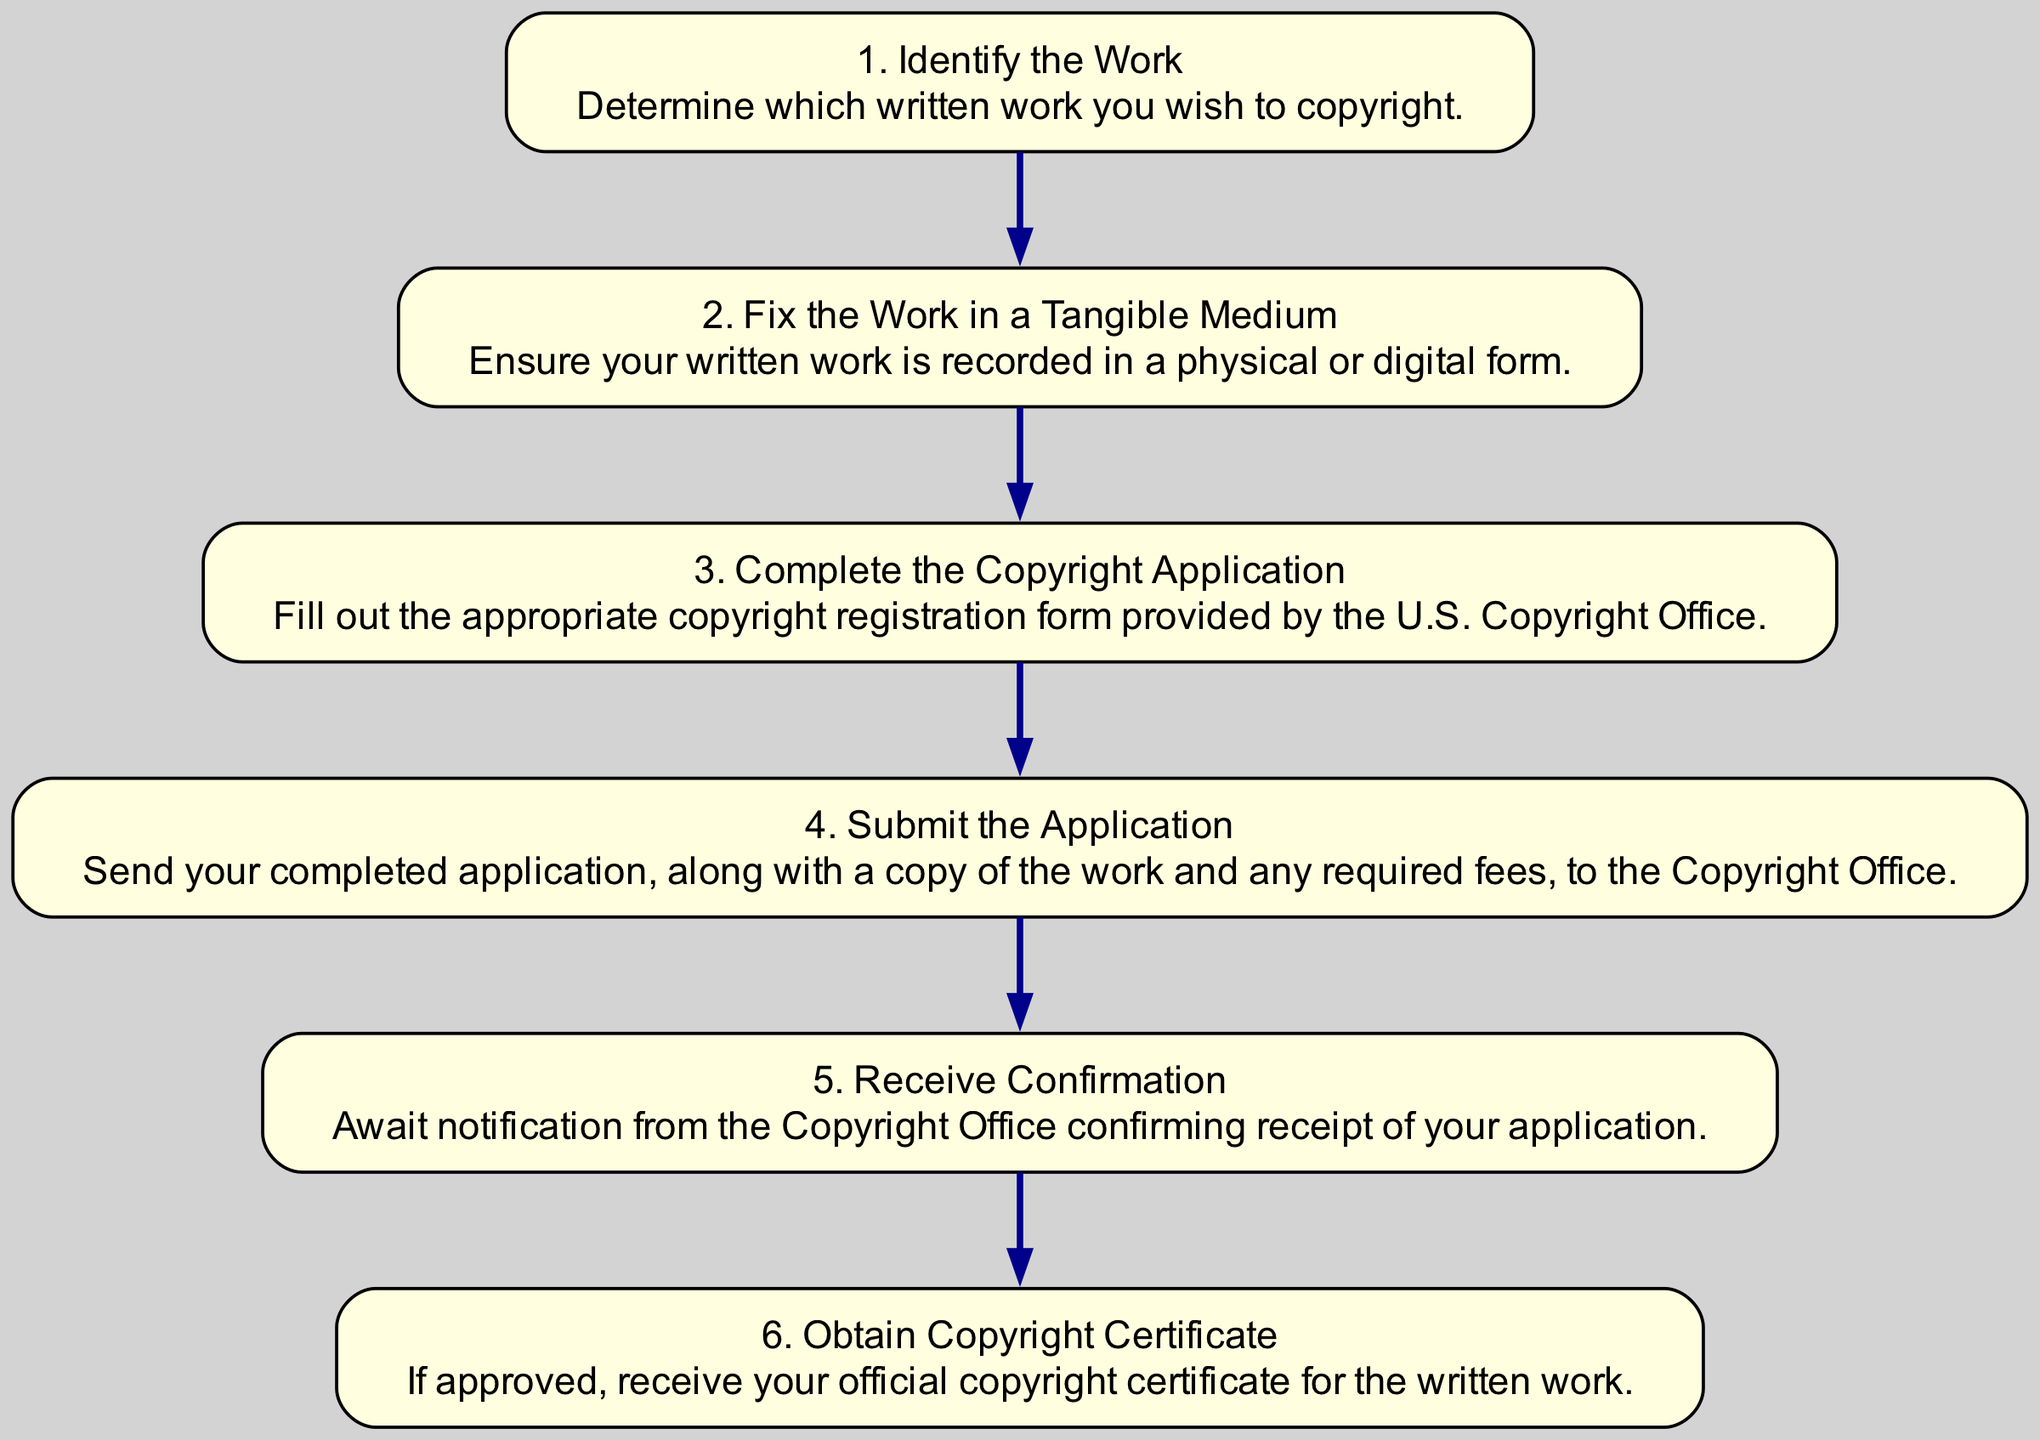What is the first step in the process? The first step shown in the diagram is "Identify the Work," indicating it is the initial action one must take when seeking copyright.
Answer: Identify the Work How many total steps are included in the copyright application process? There are six steps listed in the diagram, representing all the actions needed to obtain copyright for a written work.
Answer: 6 What follows after "Fix the Work in a Tangible Medium"? The diagram indicates that after "Fix the Work in a Tangible Medium," the next step is "Complete the Copyright Application."
Answer: Complete the Copyright Application What confirmation is received after submitting the application? The diagram shows that after submission, one receives "Confirmation" from the Copyright Office, which acknowledges receipt of the application.
Answer: Confirmation What is the last step in obtaining copyright? According to the diagram, the final step to complete the copyright process is to "Obtain Copyright Certificate."
Answer: Obtain Copyright Certificate Which step comes directly after "Complete the Copyright Application"? Following "Complete the Copyright Application," the next step in the sequence is "Submit the Application," as shown in the diagram.
Answer: Submit the Application Are the steps in the diagram sequential or can they occur simultaneously? The steps outlined in the diagram are sequential, as each action follows the previous one in a specified order toward obtaining copyright.
Answer: Sequential 